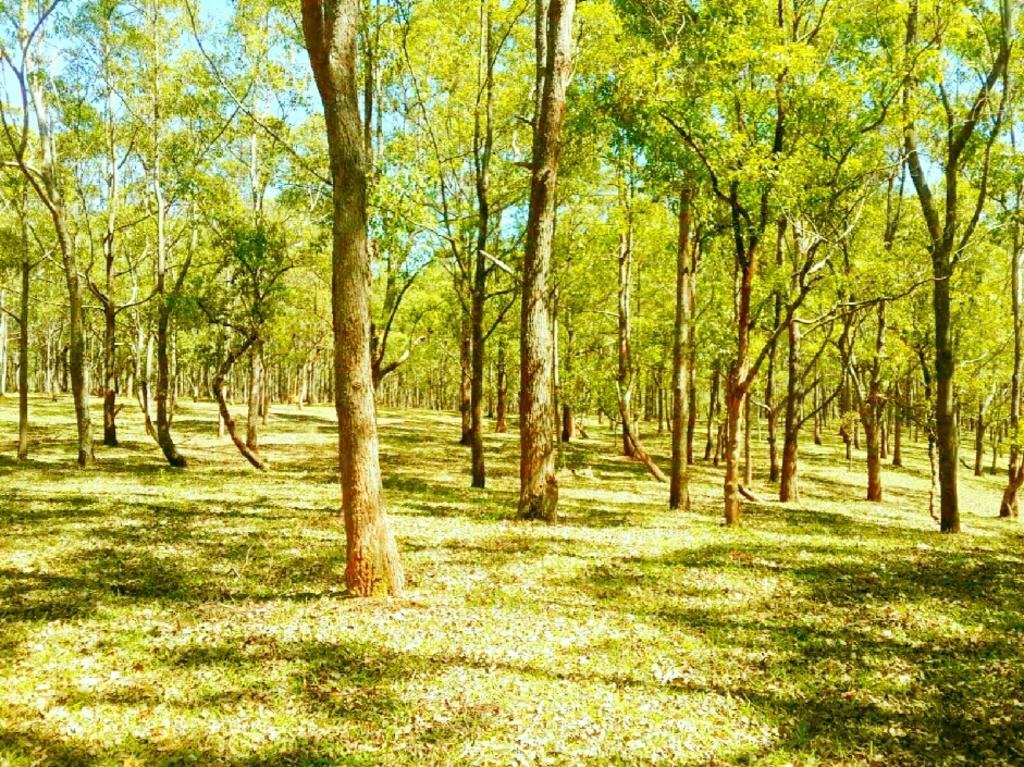What type of vegetation is present on the ground in the image? There is grass on the ground in the image. What other natural elements can be seen in the image? There are many trees in the image. What is visible in the background of the image? The sky is visible in the background of the image. What direction is the salt being poured in the image? There is no salt present in the image, so it cannot be determined in which direction it might be poured. 